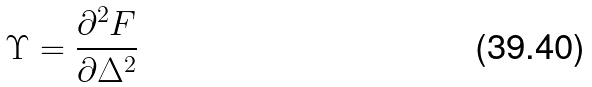<formula> <loc_0><loc_0><loc_500><loc_500>\Upsilon = \frac { \partial ^ { 2 } F } { \partial \Delta ^ { 2 } }</formula> 